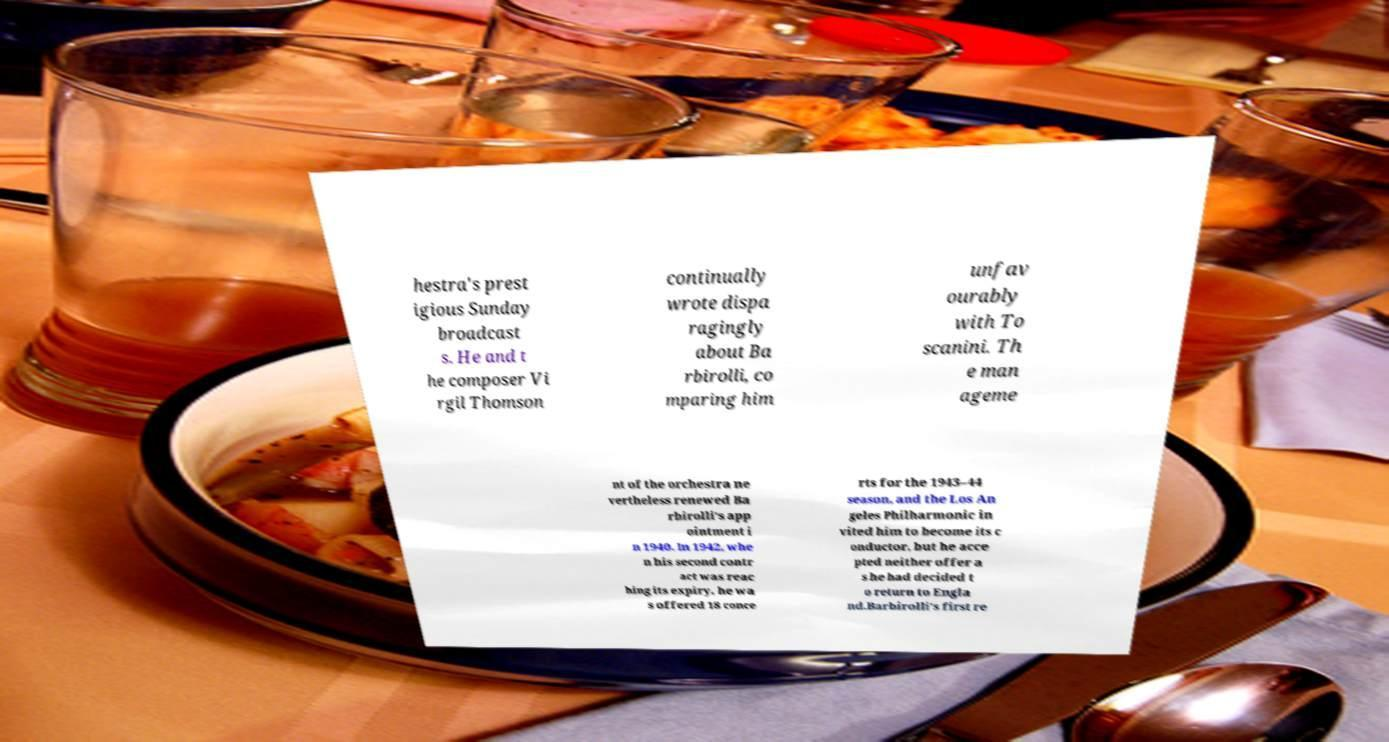Please identify and transcribe the text found in this image. hestra's prest igious Sunday broadcast s. He and t he composer Vi rgil Thomson continually wrote dispa ragingly about Ba rbirolli, co mparing him unfav ourably with To scanini. Th e man ageme nt of the orchestra ne vertheless renewed Ba rbirolli's app ointment i n 1940. In 1942, whe n his second contr act was reac hing its expiry, he wa s offered 18 conce rts for the 1943–44 season, and the Los An geles Philharmonic in vited him to become its c onductor, but he acce pted neither offer a s he had decided t o return to Engla nd.Barbirolli's first re 